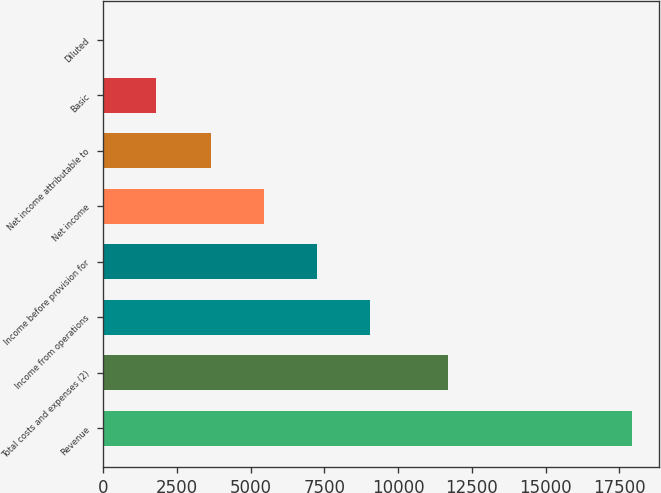Convert chart. <chart><loc_0><loc_0><loc_500><loc_500><bar_chart><fcel>Revenue<fcel>Total costs and expenses (2)<fcel>Income from operations<fcel>Income before provision for<fcel>Net income<fcel>Net income attributable to<fcel>Basic<fcel>Diluted<nl><fcel>17928<fcel>11703<fcel>9047.01<fcel>7254.34<fcel>5461.67<fcel>3669<fcel>1793.96<fcel>1.29<nl></chart> 